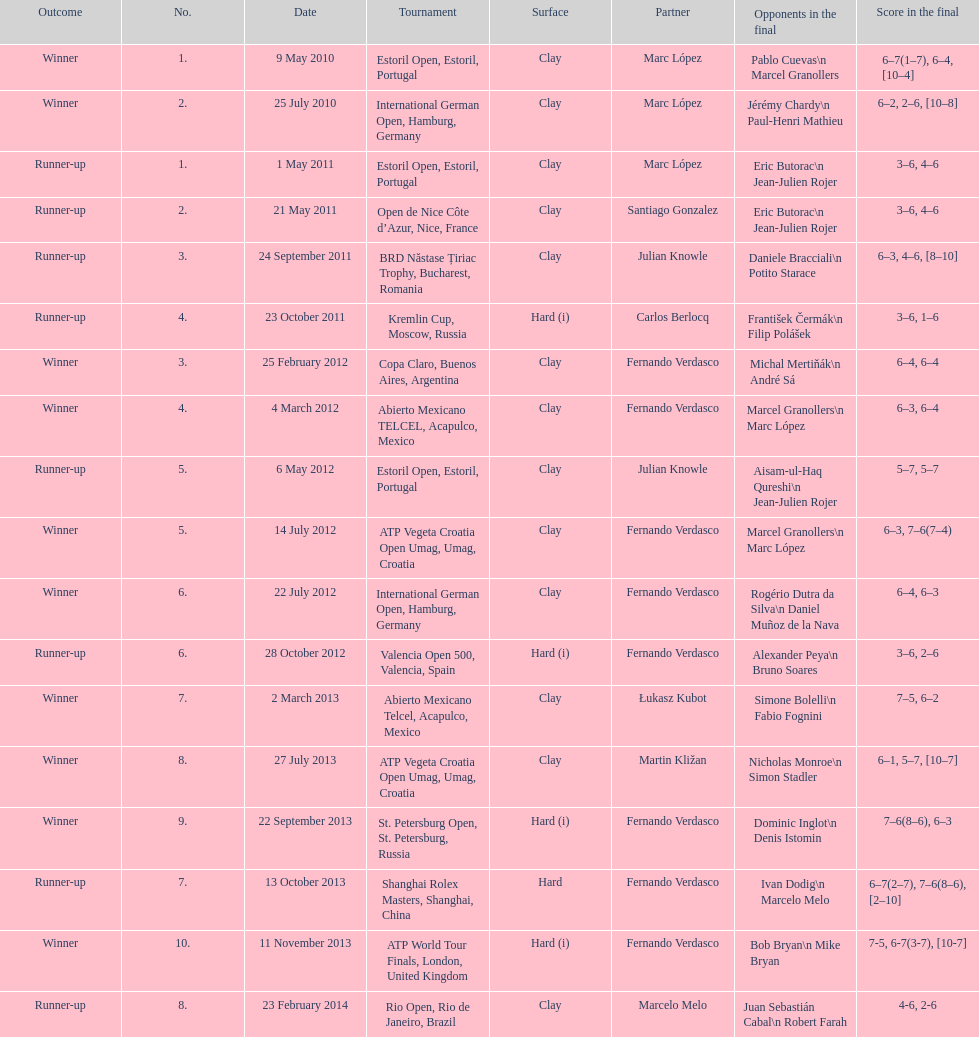What is the total number of runner-ups listed on the chart? 8. 